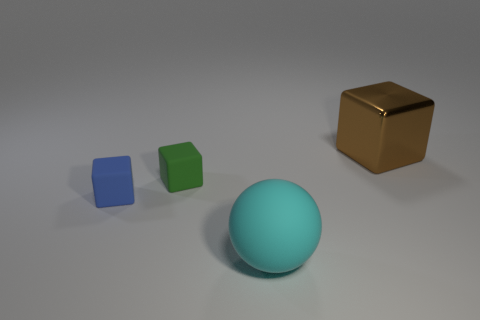How many metal objects are large cyan objects or big gray cylinders?
Your response must be concise. 0. Are there any other things that have the same size as the green matte object?
Provide a succinct answer. Yes. There is a matte object that is left of the matte object behind the small blue rubber cube; what is its shape?
Keep it short and to the point. Cube. Is the material of the object behind the small green matte object the same as the big object that is to the left of the brown shiny object?
Give a very brief answer. No. There is a big object that is behind the cyan matte thing; how many blue matte cubes are in front of it?
Your answer should be very brief. 1. Does the big thing to the left of the large shiny thing have the same shape as the thing that is right of the big sphere?
Make the answer very short. No. There is a block that is in front of the brown shiny object and on the right side of the blue block; what size is it?
Offer a terse response. Small. There is a metal object that is the same shape as the green matte thing; what is its color?
Your response must be concise. Brown. What is the color of the large thing in front of the thing on the right side of the cyan matte ball?
Give a very brief answer. Cyan. There is a big rubber object; what shape is it?
Offer a very short reply. Sphere. 